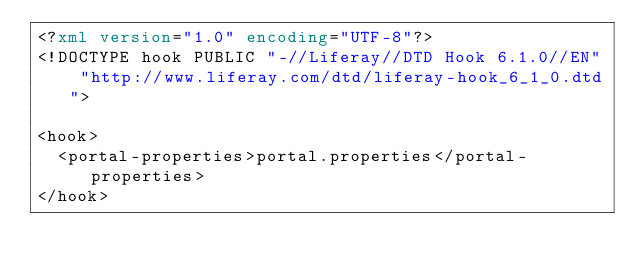<code> <loc_0><loc_0><loc_500><loc_500><_XML_><?xml version="1.0" encoding="UTF-8"?>
<!DOCTYPE hook PUBLIC "-//Liferay//DTD Hook 6.1.0//EN" "http://www.liferay.com/dtd/liferay-hook_6_1_0.dtd">

<hook>
	<portal-properties>portal.properties</portal-properties>
</hook></code> 